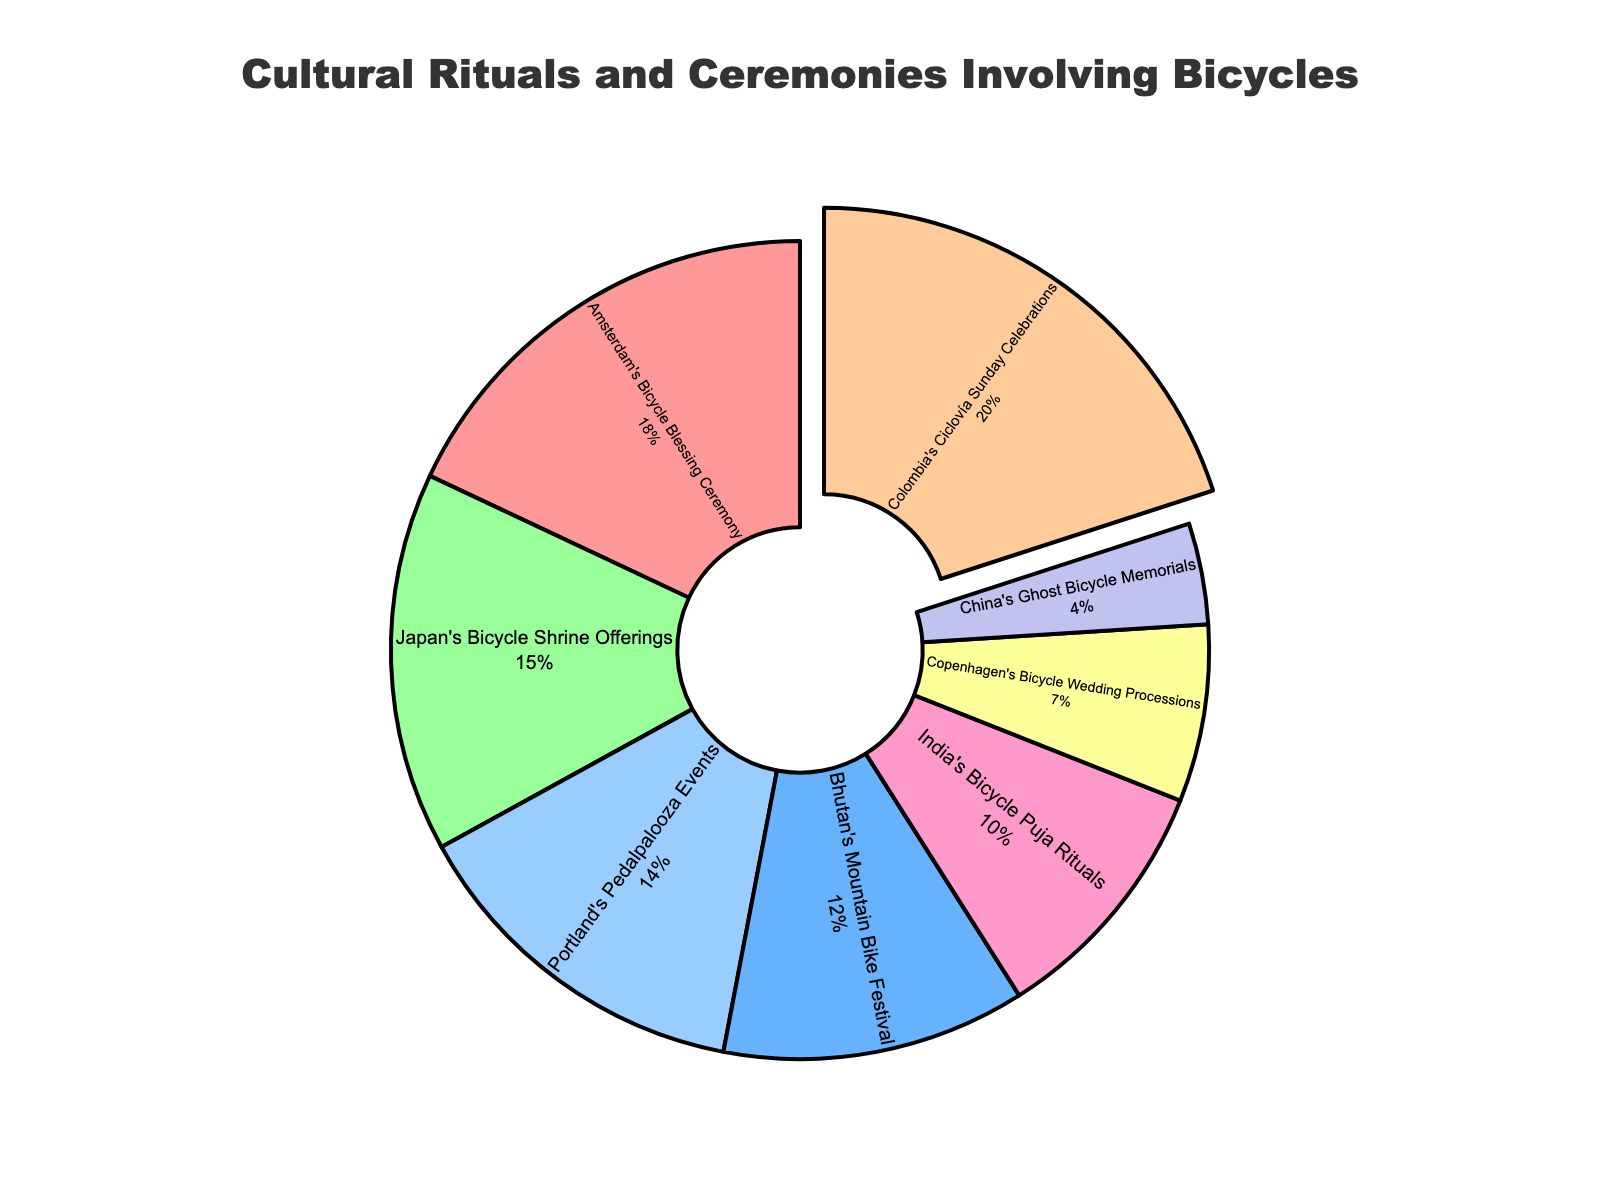What's the largest segment in the pie chart? The largest segment is determined by identifying the percentage with the highest value. As per the data, Colombia's Ciclovía Sunday Celebrations account for 20%, which is the highest.
Answer: Colombia's Ciclovía Sunday Celebrations What is the difference in percentage between the largest and smallest segments? The largest segment is Colombia's Ciclovía Sunday Celebrations at 20%, and the smallest is China's Ghost Bicycle Memorials at 4%. The difference is 20% - 4% = 16%.
Answer: 16% Which region has a higher percentage, Amsterdam's Bicycle Blessing Ceremony or Japan's Bicycle Shrine Offerings? The percentages for Amsterdam's Bicycle Blessing Ceremony and Japan's Bicycle Shrine Offerings are 18% and 15%, respectively. 18% > 15%, so Amsterdam has a higher percentage.
Answer: Amsterdam's Bicycle Blessing Ceremony What is the combined percentage of Bhutan's Mountain Bike Festival and India's Bicycle Puja Rituals? Bhutan's Mountain Bike Festival is 12% and India's Bicycle Puja Rituals is 10%. Adding these together gives 12% + 10% = 22%.
Answer: 22% How many regions have a percentage greater than 10%? By looking at each segment, we identify which ones exceed 10%. Amsterdam (18%), Bhutan (12%), Japan (15%), Colombia (20%), and Portland (14%) all exceed 10%. This totals to 5 regions.
Answer: 5 Which segment is represented by the smallest slice in the pie chart and how can you visually identify it? The smallest segment is identified by the smallest area in the pie chart, which is often easier to see if it is less prominently labeled. Here, China's Ghost Bicycle Memorials, at 4%, is visually the smallest slice.
Answer: China's Ghost Bicycle Memorials Which regions have nearly equal or the same percentage, and what is that percentage? By comparing the percentages, we see Bhutan's Mountain Bike Festival is 12% and India's Bicycle Puja Rituals is 10%. They are close but not equal. However, visually similar segments are Amsterdam's Bicycle Blessing Ceremony at 18% and Portland's Pedalpalooza Events at 14%. The only exact same values are not present in the data.
Answer: No exact same values; closest are Bhutan and India (12% and 10%) What is the total percentage of all the regions together? Since the data provided covers all regions involved in the chart and they represent the whole, the sum of the percentages should be 100%. Each percentage represents a part of a whole pie.
Answer: 100% What visual cue is used to highlight the largest segment, and which region does it represent? The chart uses the 'pull' effect to slightly separate the largest segment from the pie, making it more visually prominent. This segment represents Colombia's Ciclovía Sunday Celebrations.
Answer: Colombia's Ciclovía Sunday Celebrations What percentage do Copenhagen's Bicycle Wedding Processions and China's Ghost Bicycle Memorials contribute together? Adding the percentages of Copenhagen's Bicycle Wedding Processions and China's Ghost Bicycle Memorials gives 7% + 4% = 11%.
Answer: 11% 